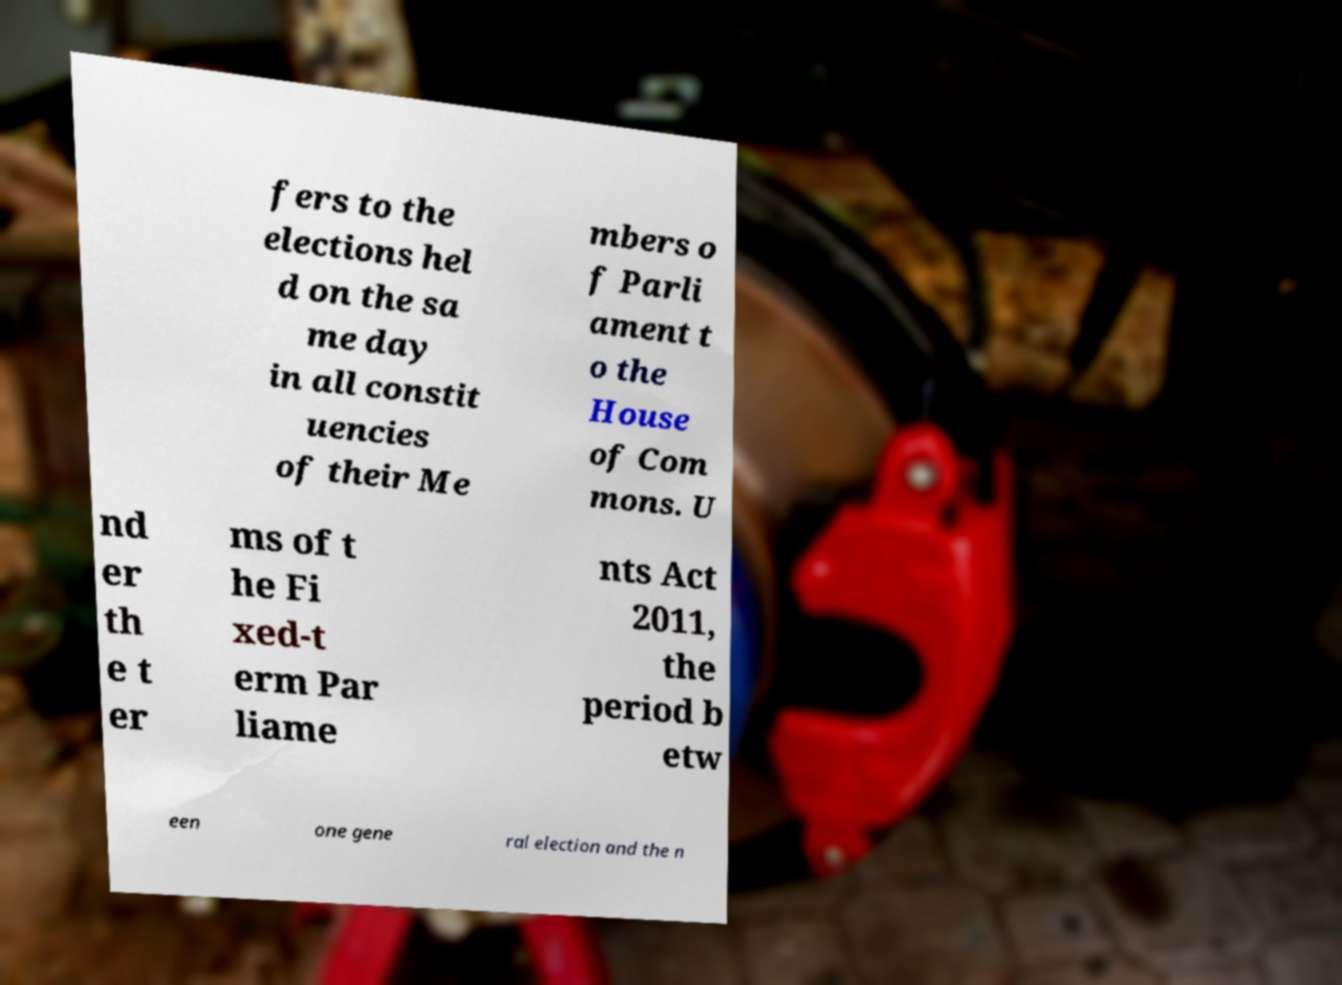Please read and relay the text visible in this image. What does it say? fers to the elections hel d on the sa me day in all constit uencies of their Me mbers o f Parli ament t o the House of Com mons. U nd er th e t er ms of t he Fi xed-t erm Par liame nts Act 2011, the period b etw een one gene ral election and the n 